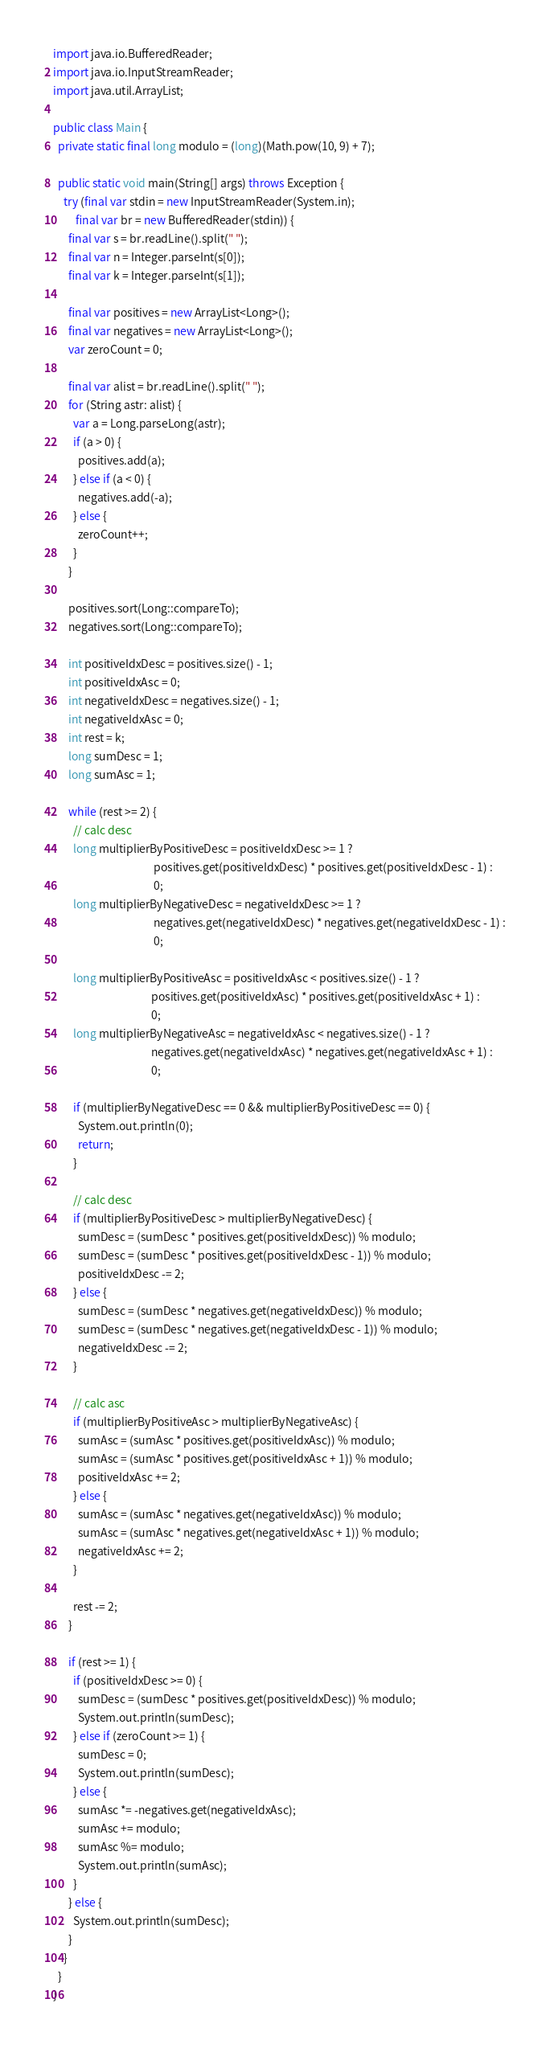Convert code to text. <code><loc_0><loc_0><loc_500><loc_500><_Java_>import java.io.BufferedReader;
import java.io.InputStreamReader;
import java.util.ArrayList;

public class Main {
  private static final long modulo = (long)(Math.pow(10, 9) + 7);

  public static void main(String[] args) throws Exception {
    try (final var stdin = new InputStreamReader(System.in);
         final var br = new BufferedReader(stdin)) {
      final var s = br.readLine().split(" ");
      final var n = Integer.parseInt(s[0]);
      final var k = Integer.parseInt(s[1]);

      final var positives = new ArrayList<Long>();
      final var negatives = new ArrayList<Long>();
      var zeroCount = 0;

      final var alist = br.readLine().split(" ");
      for (String astr: alist) {
        var a = Long.parseLong(astr);
        if (a > 0) {
          positives.add(a);
        } else if (a < 0) {
          negatives.add(-a);
        } else {
          zeroCount++;
        }
      }

      positives.sort(Long::compareTo);
      negatives.sort(Long::compareTo);

      int positiveIdxDesc = positives.size() - 1;
      int positiveIdxAsc = 0;
      int negativeIdxDesc = negatives.size() - 1;
      int negativeIdxAsc = 0;
      int rest = k;
      long sumDesc = 1;
      long sumAsc = 1;

      while (rest >= 2) {
        // calc desc
        long multiplierByPositiveDesc = positiveIdxDesc >= 1 ?
                                        positives.get(positiveIdxDesc) * positives.get(positiveIdxDesc - 1) :
                                        0;
        long multiplierByNegativeDesc = negativeIdxDesc >= 1 ?
                                        negatives.get(negativeIdxDesc) * negatives.get(negativeIdxDesc - 1) :
                                        0;

        long multiplierByPositiveAsc = positiveIdxAsc < positives.size() - 1 ?
                                       positives.get(positiveIdxAsc) * positives.get(positiveIdxAsc + 1) :
                                       0;
        long multiplierByNegativeAsc = negativeIdxAsc < negatives.size() - 1 ?
                                       negatives.get(negativeIdxAsc) * negatives.get(negativeIdxAsc + 1) :
                                       0;

        if (multiplierByNegativeDesc == 0 && multiplierByPositiveDesc == 0) {
          System.out.println(0);
          return;
        }

        // calc desc
        if (multiplierByPositiveDesc > multiplierByNegativeDesc) {
          sumDesc = (sumDesc * positives.get(positiveIdxDesc)) % modulo;
          sumDesc = (sumDesc * positives.get(positiveIdxDesc - 1)) % modulo;
          positiveIdxDesc -= 2;
        } else {
          sumDesc = (sumDesc * negatives.get(negativeIdxDesc)) % modulo;
          sumDesc = (sumDesc * negatives.get(negativeIdxDesc - 1)) % modulo;
          negativeIdxDesc -= 2;
        }

        // calc asc
        if (multiplierByPositiveAsc > multiplierByNegativeAsc) {
          sumAsc = (sumAsc * positives.get(positiveIdxAsc)) % modulo;
          sumAsc = (sumAsc * positives.get(positiveIdxAsc + 1)) % modulo;
          positiveIdxAsc += 2;
        } else {
          sumAsc = (sumAsc * negatives.get(negativeIdxAsc)) % modulo;
          sumAsc = (sumAsc * negatives.get(negativeIdxAsc + 1)) % modulo;
          negativeIdxAsc += 2;
        }

        rest -= 2;
      }

      if (rest >= 1) {
        if (positiveIdxDesc >= 0) {
          sumDesc = (sumDesc * positives.get(positiveIdxDesc)) % modulo;
          System.out.println(sumDesc);
        } else if (zeroCount >= 1) {
          sumDesc = 0;
          System.out.println(sumDesc);
        } else {
          sumAsc *= -negatives.get(negativeIdxAsc);
          sumAsc += modulo;
          sumAsc %= modulo;
          System.out.println(sumAsc);
        }
      } else {
        System.out.println(sumDesc);
      }
    }
  }
}
</code> 